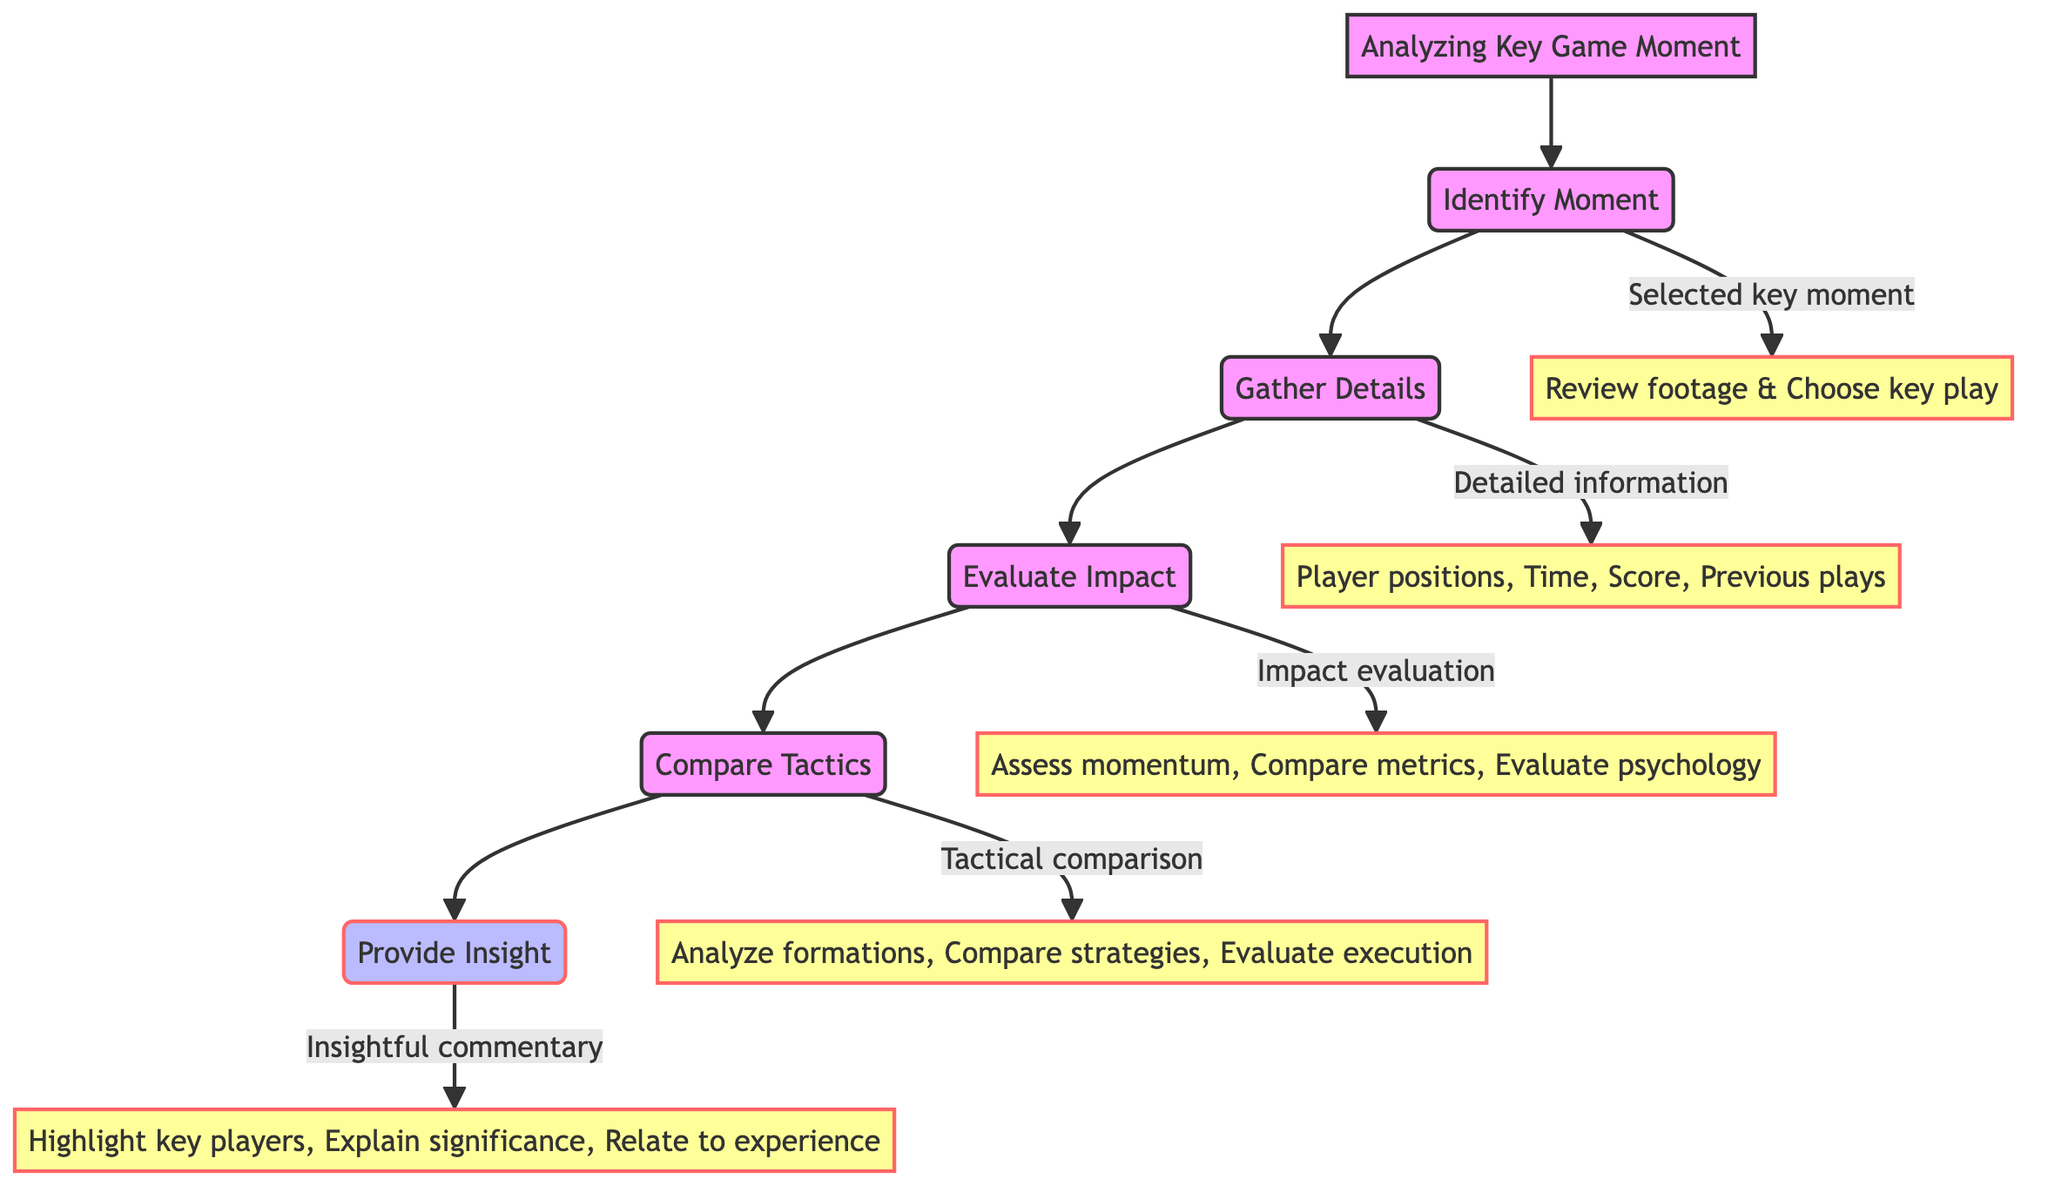What is the first action in the flowchart? The first action in the flowchart is located under the "Identify Moment" node and is "Review game footage." This indicates the initial task in analyzing a key game moment.
Answer: Review game footage What is the output of the "Evaluate Impact" process? The output of the "Evaluate Impact" process is found directly beneath its node, which is "Impact evaluation report." This tells us the result expected after completing this evaluation.
Answer: Impact evaluation report How many main processes are listed in the flowchart? By counting the nodes labeled as processes, there are five: Identify Moment, Gather Details, Evaluate Impact, Compare Tactics, and Provide Insight. This total includes all main stages of the analysis.
Answer: 5 What actions are part of the "Gather Details" process? The actions listed under "Gather Details" include collecting information such as player positions, time on the clock, score at the moment, and previous plays leading up to the moment. These are essential for gathering all relevant details.
Answer: Player positions, Time on the clock, Score at the moment, Previous plays leading up to the moment Which output follows after the "Provide Insight" process? The output that follows after "Provide Insight" is "Insightful commentary." This output represents the final deliverable of the analysis process.
Answer: Insightful commentary What is the relationship between "Evaluate Impact" and "Gather Details"? "Evaluate Impact" is a subsequent process that follows "Gather Details," indicating that gathering information is essential before evaluating the impact of the moment on the game's outcome. This shows a sequential dependency.
Answer: Evaluate Impact follows Gather Details Which process involves analyzing "offensive and defensive formations"? The "Compare Tactics" process involves the analysis of "offensive and defensive formations." This is a specific action mentioned under that node.
Answer: Compare Tactics What is the last step of the flowchart? The last step of the flowchart is represented by the "Provide Insight" node, which culminates the entire analysis process by delivering commentary based on the previous evaluations and comparisons.
Answer: Provide Insight 